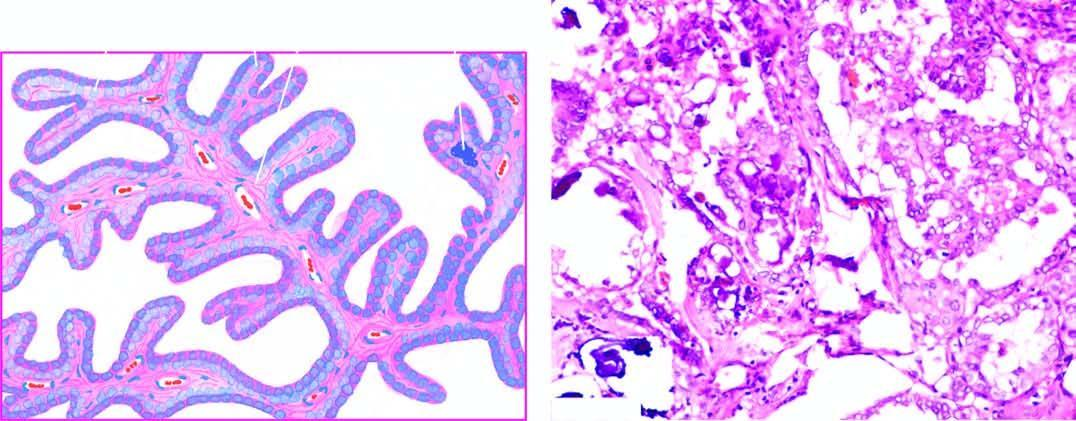does pbf show branching papillae having flbrovascular stalk covered by a single layer of cuboidal cells having ground-glass nuclei?
Answer the question using a single word or phrase. No 